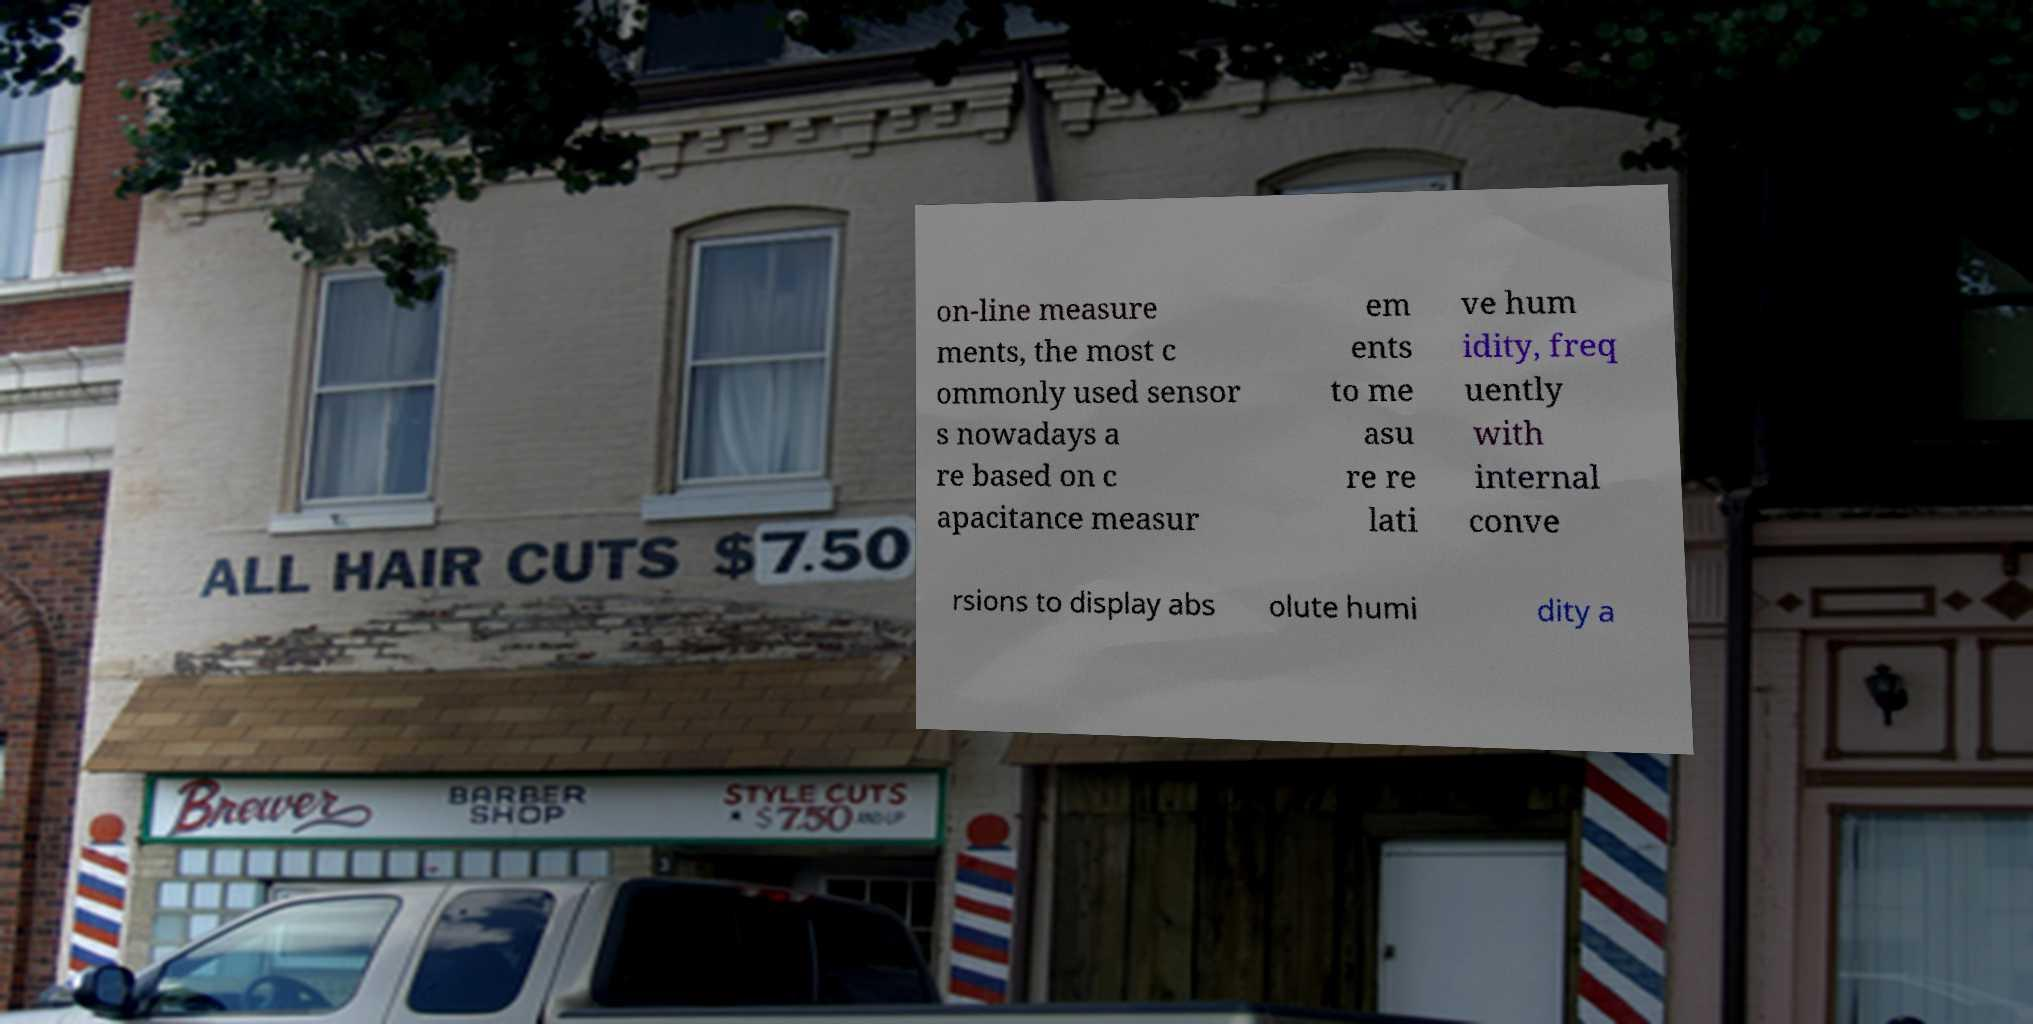Can you accurately transcribe the text from the provided image for me? on-line measure ments, the most c ommonly used sensor s nowadays a re based on c apacitance measur em ents to me asu re re lati ve hum idity, freq uently with internal conve rsions to display abs olute humi dity a 